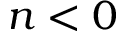<formula> <loc_0><loc_0><loc_500><loc_500>n < 0</formula> 